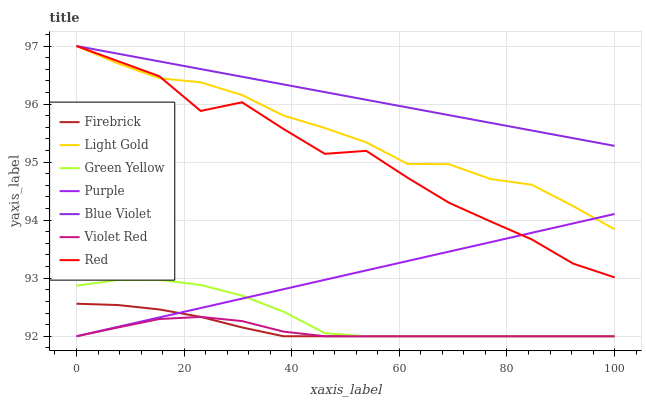Does Violet Red have the minimum area under the curve?
Answer yes or no. Yes. Does Blue Violet have the maximum area under the curve?
Answer yes or no. Yes. Does Purple have the minimum area under the curve?
Answer yes or no. No. Does Purple have the maximum area under the curve?
Answer yes or no. No. Is Purple the smoothest?
Answer yes or no. Yes. Is Red the roughest?
Answer yes or no. Yes. Is Firebrick the smoothest?
Answer yes or no. No. Is Firebrick the roughest?
Answer yes or no. No. Does Violet Red have the lowest value?
Answer yes or no. Yes. Does Red have the lowest value?
Answer yes or no. No. Does Blue Violet have the highest value?
Answer yes or no. Yes. Does Purple have the highest value?
Answer yes or no. No. Is Firebrick less than Light Gold?
Answer yes or no. Yes. Is Red greater than Green Yellow?
Answer yes or no. Yes. Does Violet Red intersect Firebrick?
Answer yes or no. Yes. Is Violet Red less than Firebrick?
Answer yes or no. No. Is Violet Red greater than Firebrick?
Answer yes or no. No. Does Firebrick intersect Light Gold?
Answer yes or no. No. 